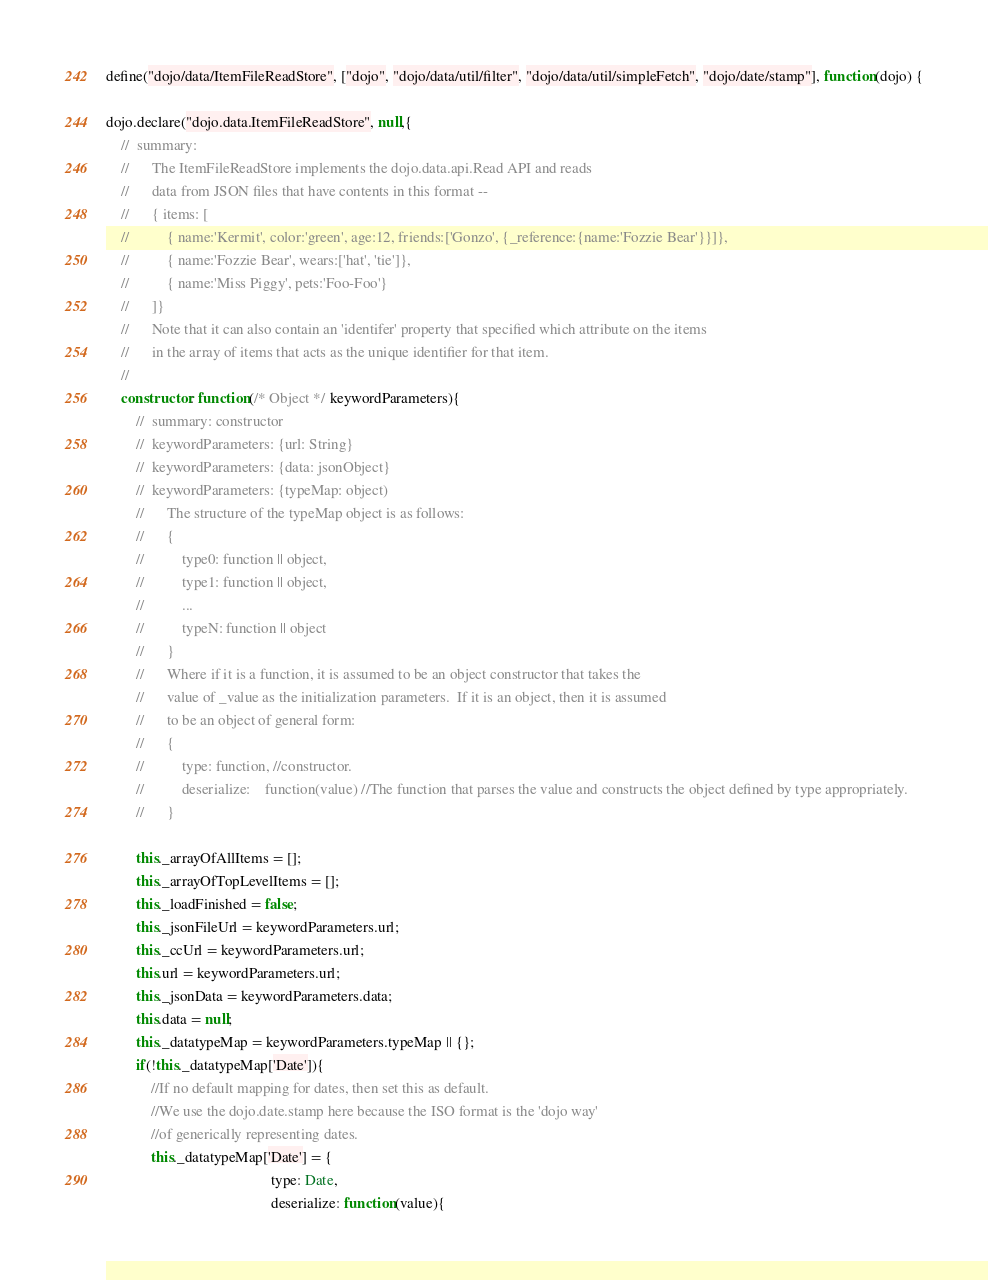<code> <loc_0><loc_0><loc_500><loc_500><_JavaScript_>define("dojo/data/ItemFileReadStore", ["dojo", "dojo/data/util/filter", "dojo/data/util/simpleFetch", "dojo/date/stamp"], function(dojo) {

dojo.declare("dojo.data.ItemFileReadStore", null,{
	//	summary:
	//		The ItemFileReadStore implements the dojo.data.api.Read API and reads
	//		data from JSON files that have contents in this format --
	//		{ items: [
	//			{ name:'Kermit', color:'green', age:12, friends:['Gonzo', {_reference:{name:'Fozzie Bear'}}]},
	//			{ name:'Fozzie Bear', wears:['hat', 'tie']},
	//			{ name:'Miss Piggy', pets:'Foo-Foo'}
	//		]}
	//		Note that it can also contain an 'identifer' property that specified which attribute on the items 
	//		in the array of items that acts as the unique identifier for that item.
	//
	constructor: function(/* Object */ keywordParameters){
		//	summary: constructor
		//	keywordParameters: {url: String}
		//	keywordParameters: {data: jsonObject}
		//	keywordParameters: {typeMap: object)
		//		The structure of the typeMap object is as follows:
		//		{
		//			type0: function || object,
		//			type1: function || object,
		//			...
		//			typeN: function || object
		//		}
		//		Where if it is a function, it is assumed to be an object constructor that takes the 
		//		value of _value as the initialization parameters.  If it is an object, then it is assumed
		//		to be an object of general form:
		//		{
		//			type: function, //constructor.
		//			deserialize:	function(value) //The function that parses the value and constructs the object defined by type appropriately.
		//		}
	
		this._arrayOfAllItems = [];
		this._arrayOfTopLevelItems = [];
		this._loadFinished = false;
		this._jsonFileUrl = keywordParameters.url;
		this._ccUrl = keywordParameters.url;
		this.url = keywordParameters.url;
		this._jsonData = keywordParameters.data;
		this.data = null;
		this._datatypeMap = keywordParameters.typeMap || {};
		if(!this._datatypeMap['Date']){
			//If no default mapping for dates, then set this as default.
			//We use the dojo.date.stamp here because the ISO format is the 'dojo way'
			//of generically representing dates.
			this._datatypeMap['Date'] = {
											type: Date,
											deserialize: function(value){</code> 